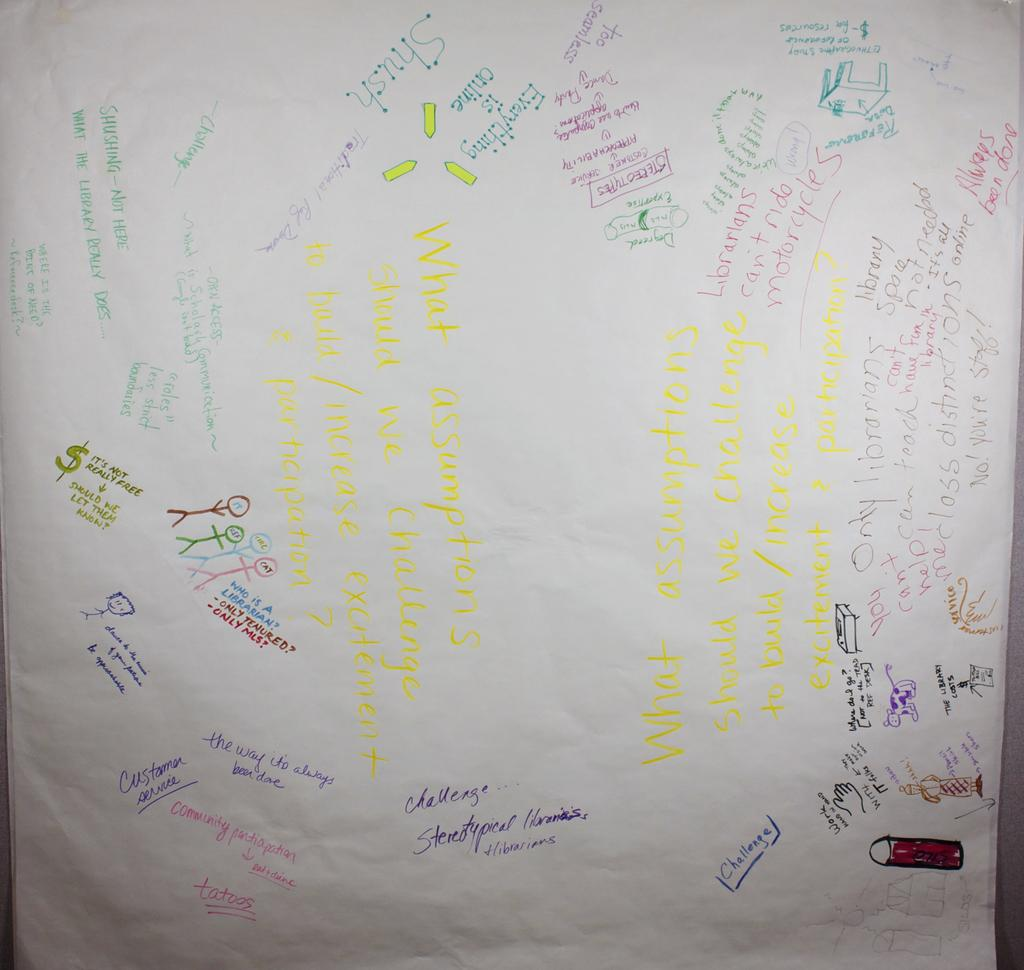<image>
Summarize the visual content of the image. A paper sign with different sayings says to work hand in hand. 